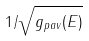<formula> <loc_0><loc_0><loc_500><loc_500>1 / \sqrt { g _ { p a v } ( E ) }</formula> 